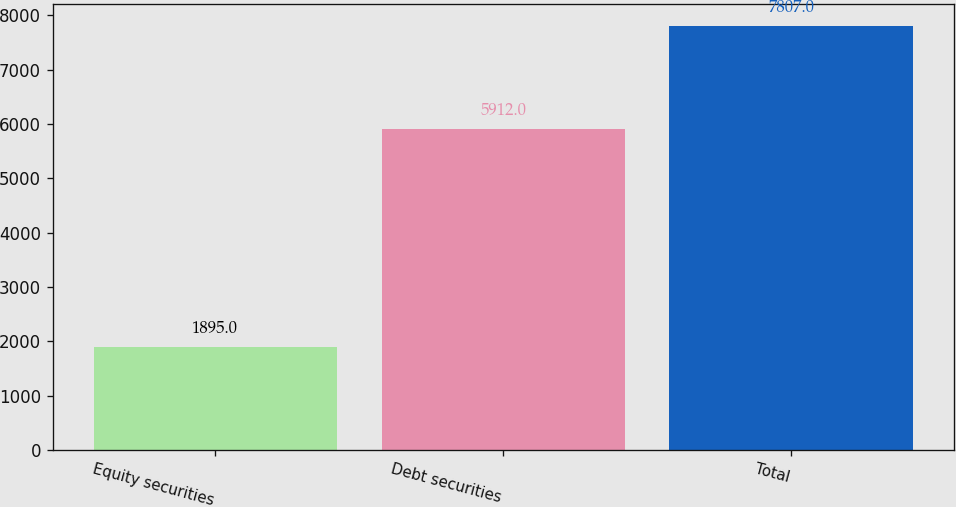<chart> <loc_0><loc_0><loc_500><loc_500><bar_chart><fcel>Equity securities<fcel>Debt securities<fcel>Total<nl><fcel>1895<fcel>5912<fcel>7807<nl></chart> 